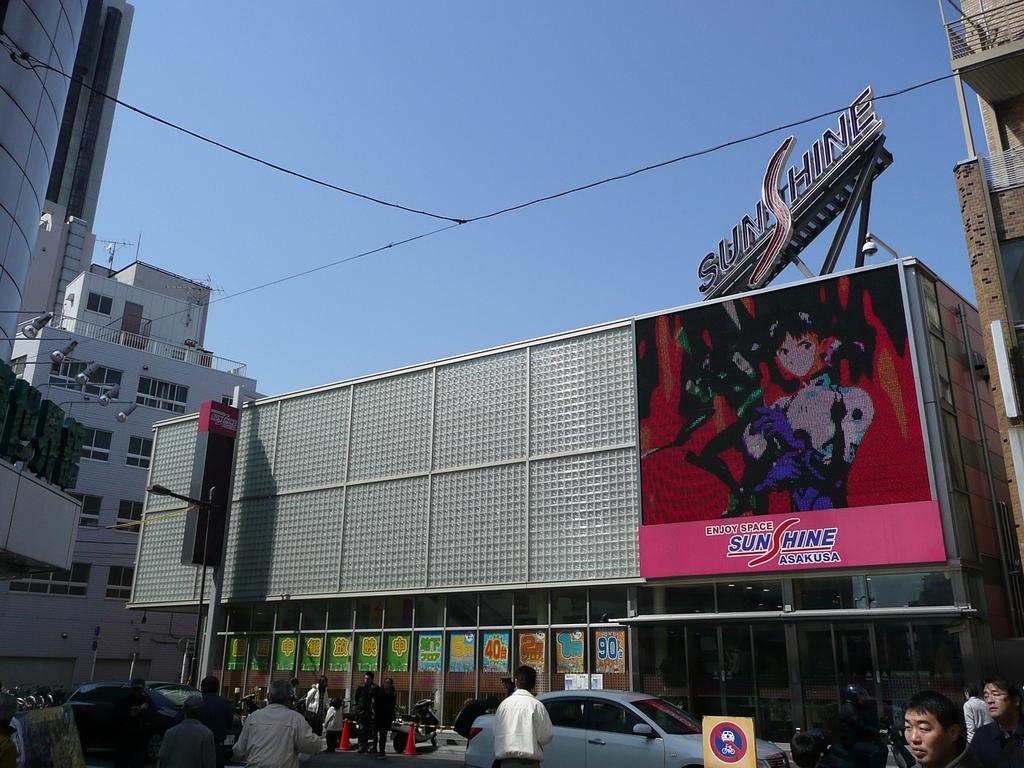What does the sign say on the building?
Give a very brief answer. Sunshine. What company is the sign advertising for?
Provide a short and direct response. Sunshine. 